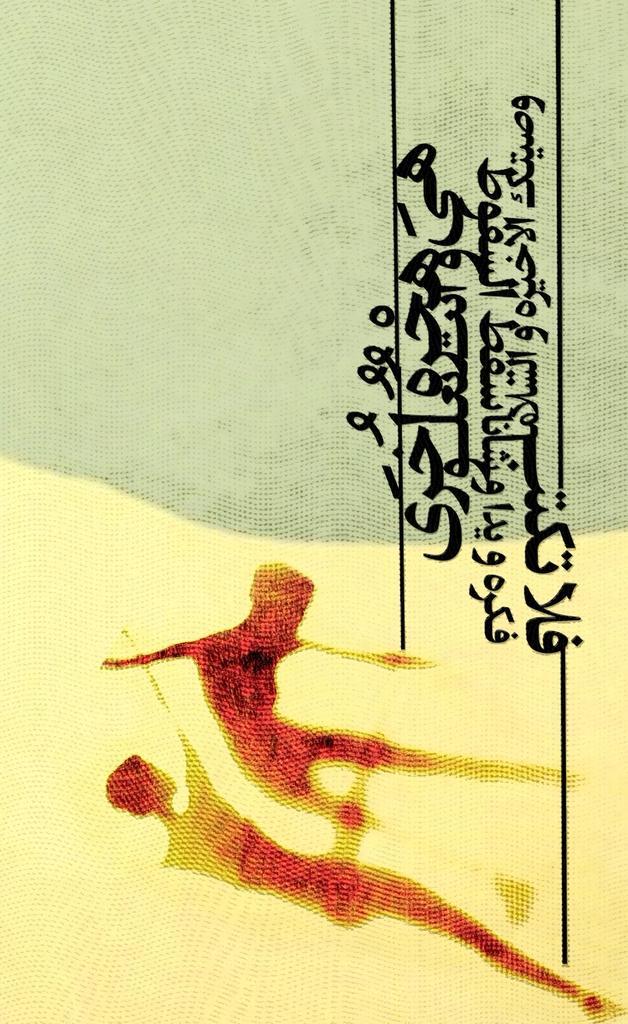In one or two sentences, can you explain what this image depicts? In this picture we can see a poster, there is some text on the right side. 